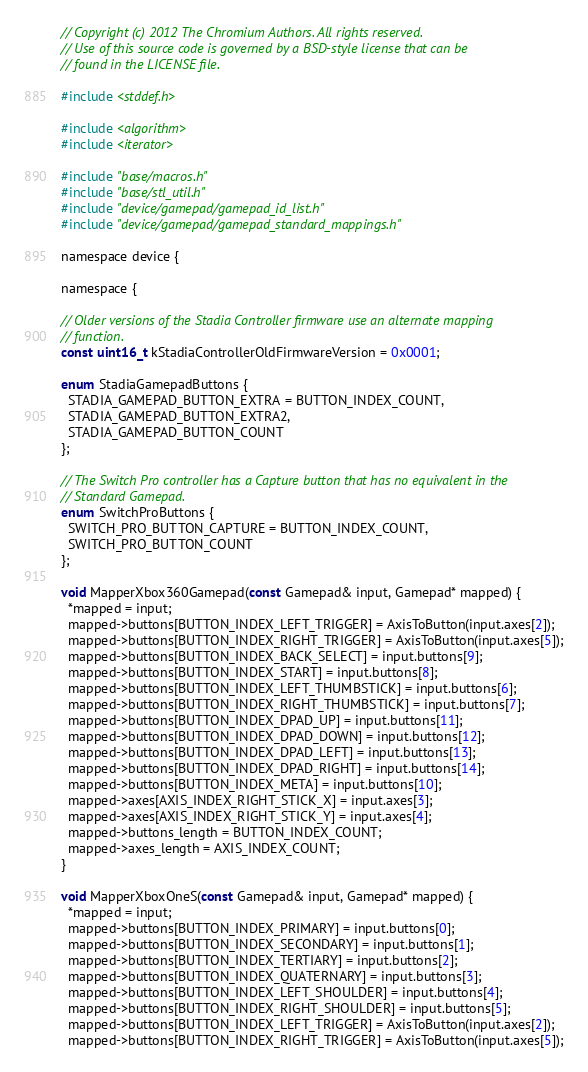<code> <loc_0><loc_0><loc_500><loc_500><_ObjectiveC_>// Copyright (c) 2012 The Chromium Authors. All rights reserved.
// Use of this source code is governed by a BSD-style license that can be
// found in the LICENSE file.

#include <stddef.h>

#include <algorithm>
#include <iterator>

#include "base/macros.h"
#include "base/stl_util.h"
#include "device/gamepad/gamepad_id_list.h"
#include "device/gamepad/gamepad_standard_mappings.h"

namespace device {

namespace {

// Older versions of the Stadia Controller firmware use an alternate mapping
// function.
const uint16_t kStadiaControllerOldFirmwareVersion = 0x0001;

enum StadiaGamepadButtons {
  STADIA_GAMEPAD_BUTTON_EXTRA = BUTTON_INDEX_COUNT,
  STADIA_GAMEPAD_BUTTON_EXTRA2,
  STADIA_GAMEPAD_BUTTON_COUNT
};

// The Switch Pro controller has a Capture button that has no equivalent in the
// Standard Gamepad.
enum SwitchProButtons {
  SWITCH_PRO_BUTTON_CAPTURE = BUTTON_INDEX_COUNT,
  SWITCH_PRO_BUTTON_COUNT
};

void MapperXbox360Gamepad(const Gamepad& input, Gamepad* mapped) {
  *mapped = input;
  mapped->buttons[BUTTON_INDEX_LEFT_TRIGGER] = AxisToButton(input.axes[2]);
  mapped->buttons[BUTTON_INDEX_RIGHT_TRIGGER] = AxisToButton(input.axes[5]);
  mapped->buttons[BUTTON_INDEX_BACK_SELECT] = input.buttons[9];
  mapped->buttons[BUTTON_INDEX_START] = input.buttons[8];
  mapped->buttons[BUTTON_INDEX_LEFT_THUMBSTICK] = input.buttons[6];
  mapped->buttons[BUTTON_INDEX_RIGHT_THUMBSTICK] = input.buttons[7];
  mapped->buttons[BUTTON_INDEX_DPAD_UP] = input.buttons[11];
  mapped->buttons[BUTTON_INDEX_DPAD_DOWN] = input.buttons[12];
  mapped->buttons[BUTTON_INDEX_DPAD_LEFT] = input.buttons[13];
  mapped->buttons[BUTTON_INDEX_DPAD_RIGHT] = input.buttons[14];
  mapped->buttons[BUTTON_INDEX_META] = input.buttons[10];
  mapped->axes[AXIS_INDEX_RIGHT_STICK_X] = input.axes[3];
  mapped->axes[AXIS_INDEX_RIGHT_STICK_Y] = input.axes[4];
  mapped->buttons_length = BUTTON_INDEX_COUNT;
  mapped->axes_length = AXIS_INDEX_COUNT;
}

void MapperXboxOneS(const Gamepad& input, Gamepad* mapped) {
  *mapped = input;
  mapped->buttons[BUTTON_INDEX_PRIMARY] = input.buttons[0];
  mapped->buttons[BUTTON_INDEX_SECONDARY] = input.buttons[1];
  mapped->buttons[BUTTON_INDEX_TERTIARY] = input.buttons[2];
  mapped->buttons[BUTTON_INDEX_QUATERNARY] = input.buttons[3];
  mapped->buttons[BUTTON_INDEX_LEFT_SHOULDER] = input.buttons[4];
  mapped->buttons[BUTTON_INDEX_RIGHT_SHOULDER] = input.buttons[5];
  mapped->buttons[BUTTON_INDEX_LEFT_TRIGGER] = AxisToButton(input.axes[2]);
  mapped->buttons[BUTTON_INDEX_RIGHT_TRIGGER] = AxisToButton(input.axes[5]);</code> 